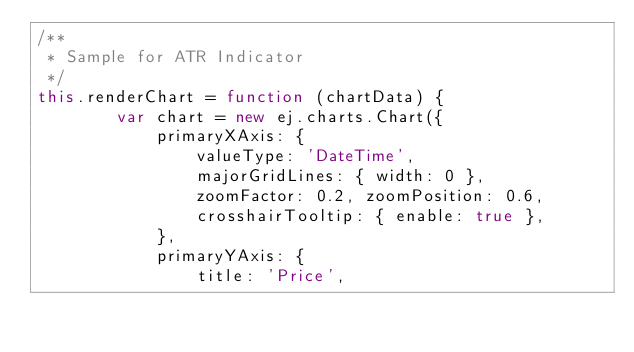Convert code to text. <code><loc_0><loc_0><loc_500><loc_500><_JavaScript_>/**
 * Sample for ATR Indicator
 */
this.renderChart = function (chartData) {
        var chart = new ej.charts.Chart({
            primaryXAxis: {
                valueType: 'DateTime',
                majorGridLines: { width: 0 },
                zoomFactor: 0.2, zoomPosition: 0.6,
                crosshairTooltip: { enable: true },
            },
            primaryYAxis: {
                title: 'Price',</code> 